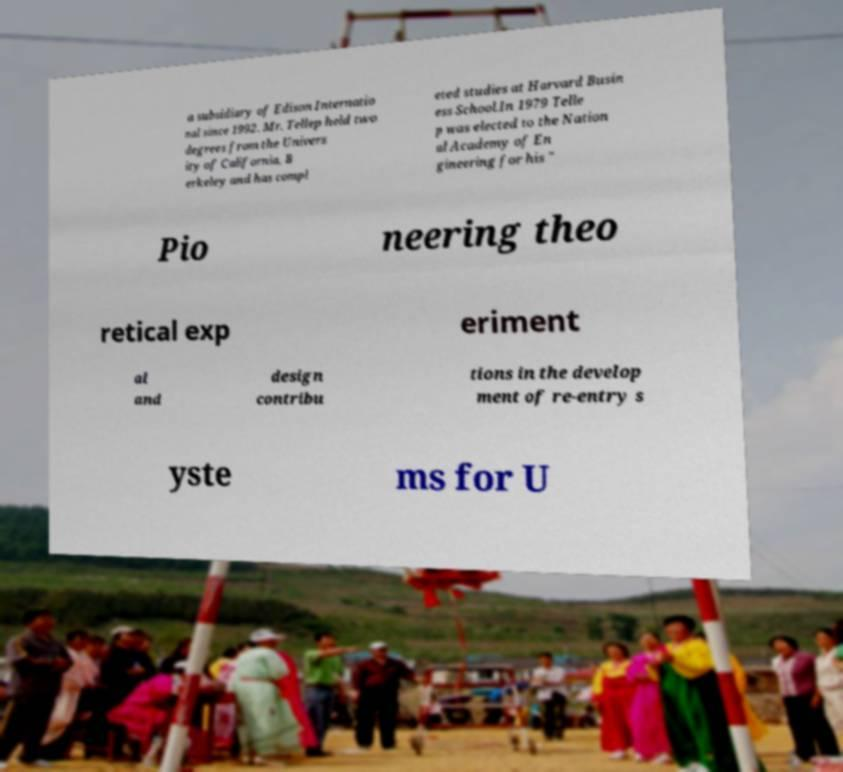Can you read and provide the text displayed in the image?This photo seems to have some interesting text. Can you extract and type it out for me? a subsidiary of Edison Internatio nal since 1992. Mr. Tellep held two degrees from the Univers ity of California, B erkeley and has compl eted studies at Harvard Busin ess School.In 1979 Telle p was elected to the Nation al Academy of En gineering for his " Pio neering theo retical exp eriment al and design contribu tions in the develop ment of re-entry s yste ms for U 